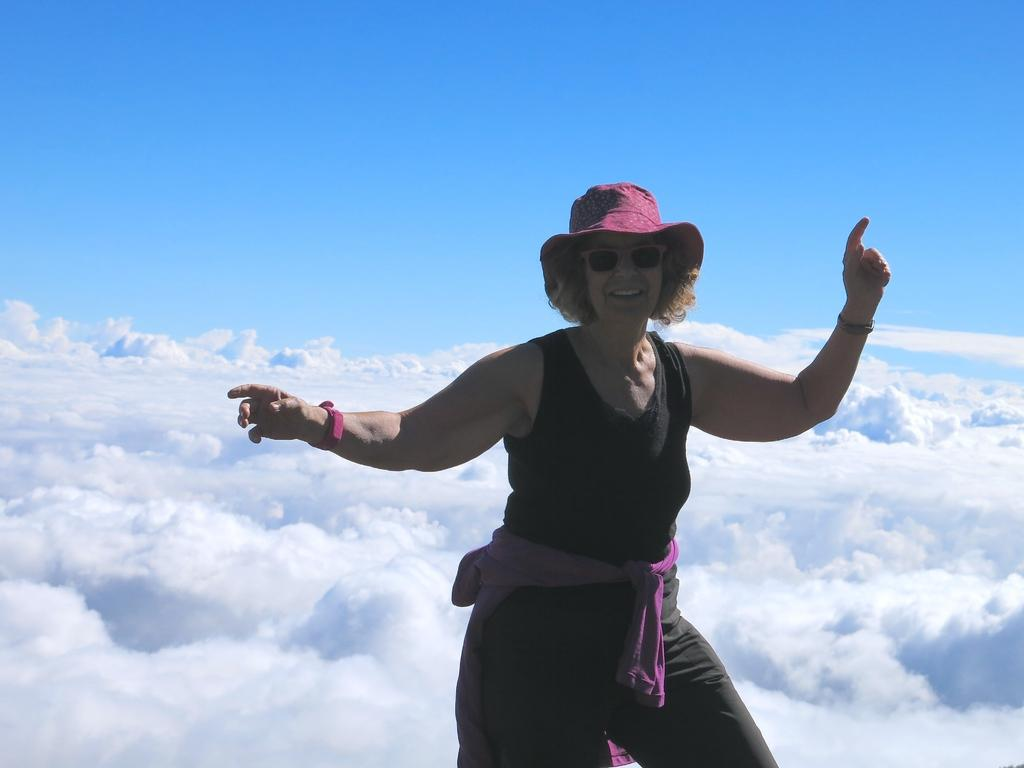Who is the main subject in the image? There is a woman in the image. What is the woman doing in the image? The woman is dancing. What expression does the woman have in the image? The woman is smiling. What can be seen in the background of the image? There are clouds and the sky visible in the background of the image. How many girls are participating in the selection process in the image? There is no mention of a selection process or any girls in the image; it features a woman dancing. 